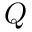<formula> <loc_0><loc_0><loc_500><loc_500>Q</formula> 